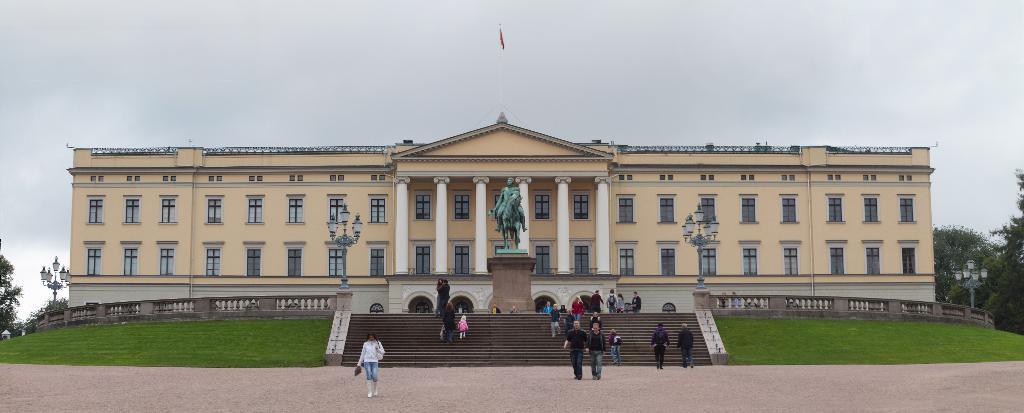Could you give a brief overview of what you see in this image? In this image in the center there are persons walking and there is grass on the ground and there is a statue on the pillar, there are poles. In the background there is a building and on the top of the building, there is a flag and there are trees and the sky is cloudy. 